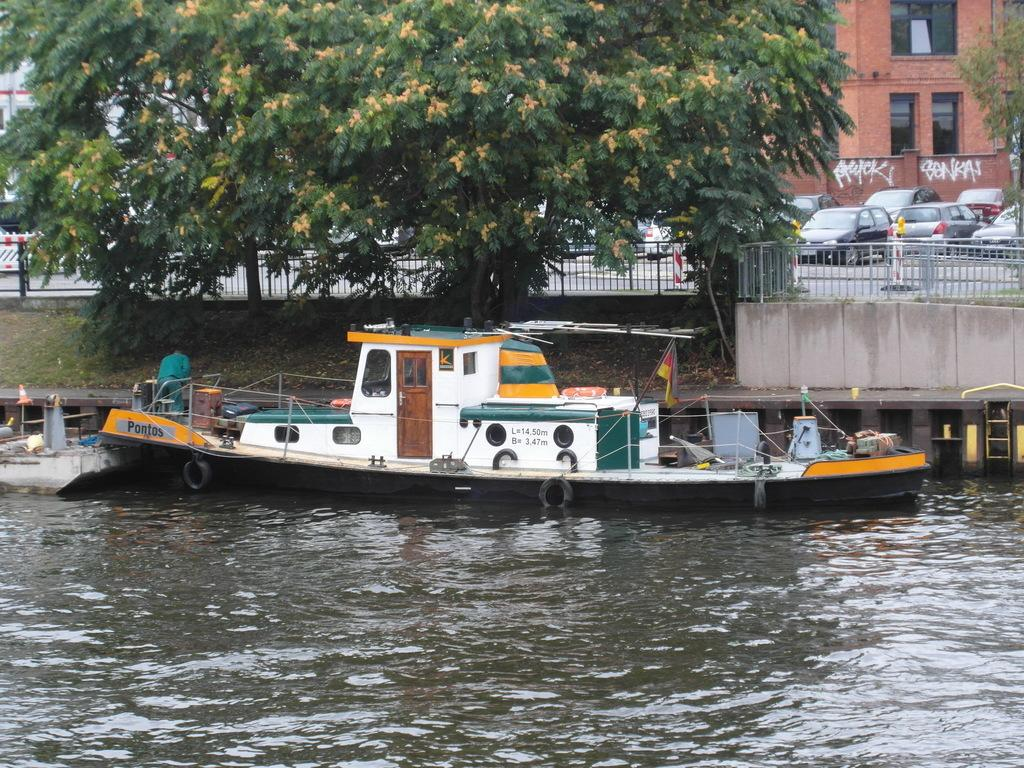What is the main subject of the image? The main subject of the image is water. What is located in the water? There is a boat in the water. Who is on the boat? There is a man on the boat. What can be seen in the background of the image? There is a tree, cars, and a brown-colored building in the background of the image. What type of pin can be seen holding the boat to the water in the image? There is no pin present in the image; the boat is floating on the water. What color is the silver hose used by the man on the boat in the image? There is no hose present in the image, and the man is not using any tools or equipment. 